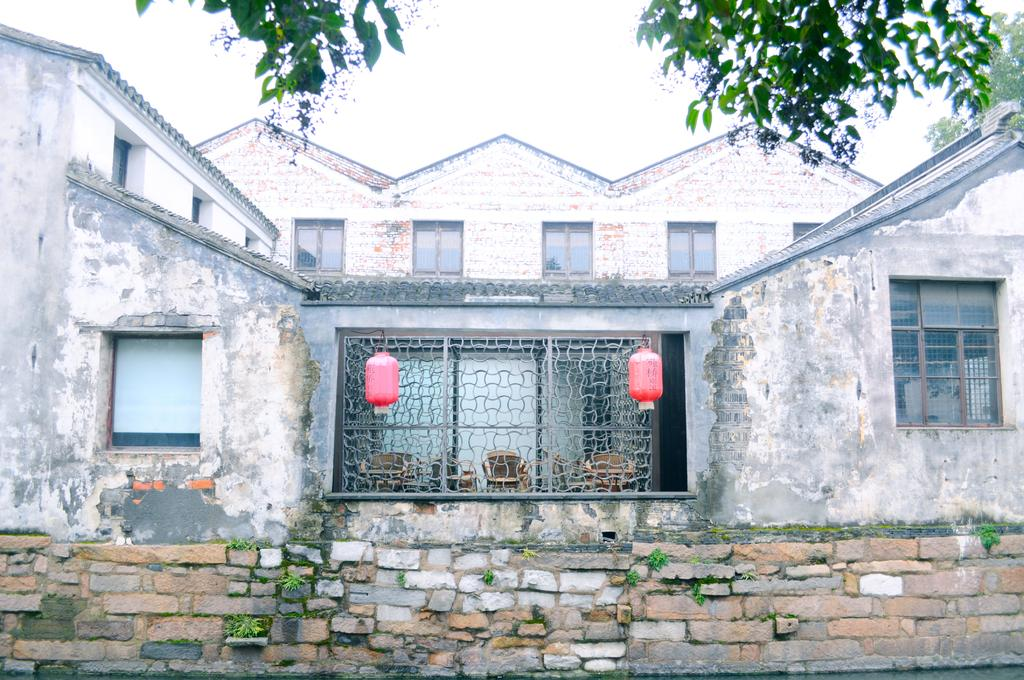What type of structures are visible in the image? There are houses in the image. What architectural features can be seen on the houses? There are windows and grilles visible on the houses. What is hung on the windows in the image? There are two objects hung on the window. What type of vegetation is present in the image? There are trees and grass in the image. What part of the natural environment is visible in the image? The sky is visible in the image. How many chickens can be seen in the image? There are no chickens present in the image. What type of animal is interacting with the objects hung on the window? There are no animals present in the image; only the objects hung on the window can be seen. 